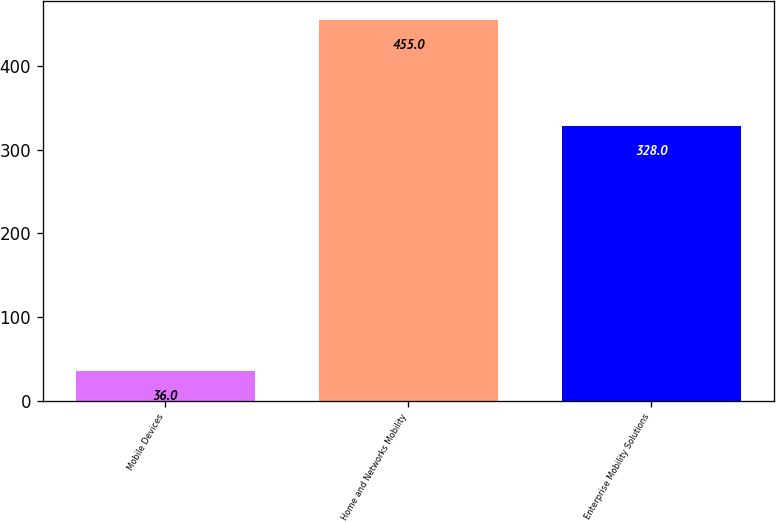<chart> <loc_0><loc_0><loc_500><loc_500><bar_chart><fcel>Mobile Devices<fcel>Home and Networks Mobility<fcel>Enterprise Mobility Solutions<nl><fcel>36<fcel>455<fcel>328<nl></chart> 